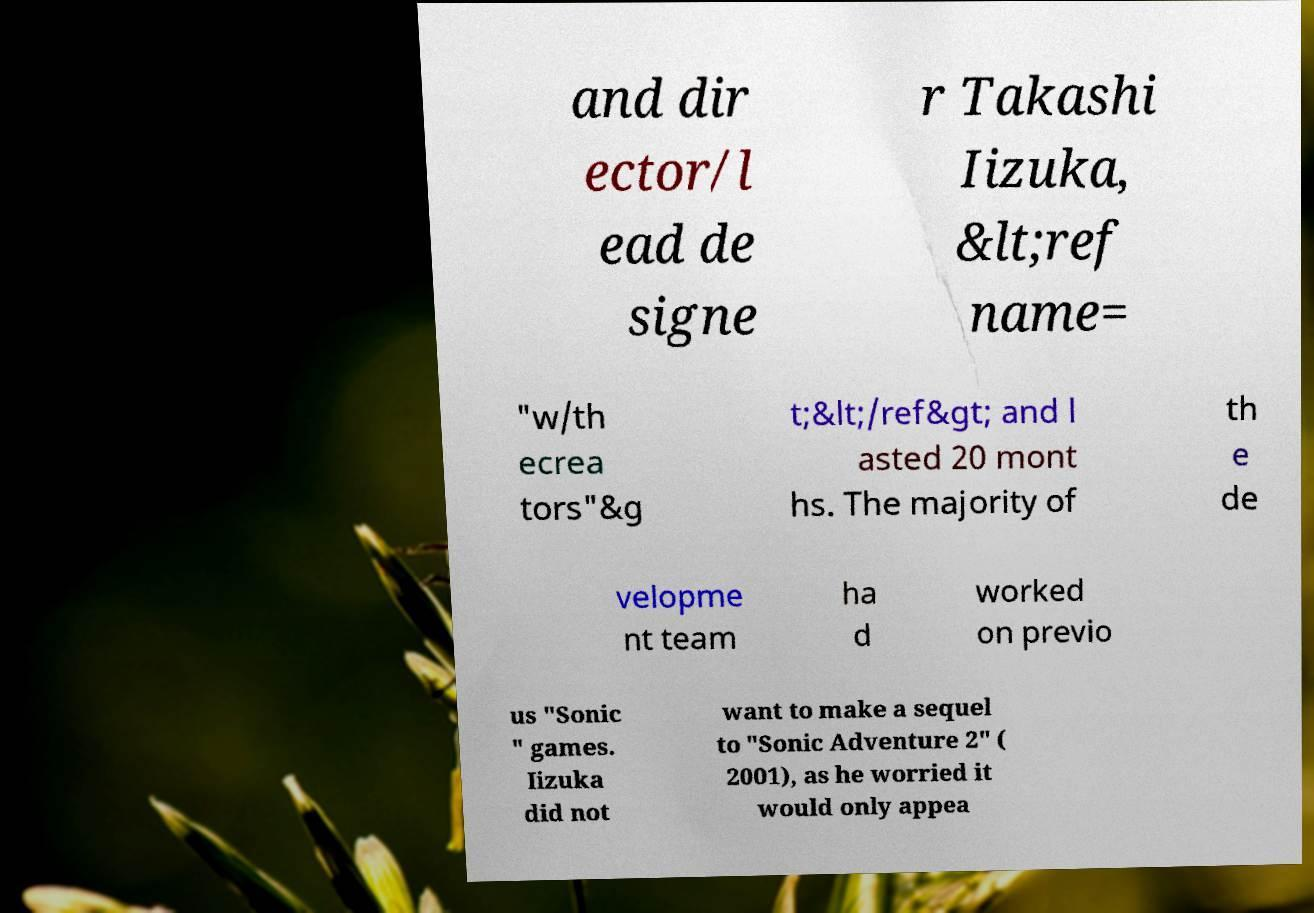Can you accurately transcribe the text from the provided image for me? and dir ector/l ead de signe r Takashi Iizuka, &lt;ref name= "w/th ecrea tors"&g t;&lt;/ref&gt; and l asted 20 mont hs. The majority of th e de velopme nt team ha d worked on previo us "Sonic " games. Iizuka did not want to make a sequel to "Sonic Adventure 2" ( 2001), as he worried it would only appea 